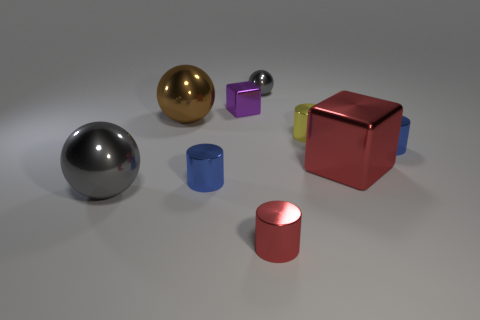Subtract all yellow cylinders. How many gray balls are left? 2 Subtract all gray balls. How many balls are left? 1 Add 1 red shiny cylinders. How many objects exist? 10 Subtract all yellow cylinders. How many cylinders are left? 3 Subtract all balls. How many objects are left? 6 Subtract all cyan spheres. Subtract all gray cylinders. How many spheres are left? 3 Add 3 big metallic spheres. How many big metallic spheres are left? 5 Add 2 yellow shiny cylinders. How many yellow shiny cylinders exist? 3 Subtract 0 gray blocks. How many objects are left? 9 Subtract all shiny blocks. Subtract all large gray metallic spheres. How many objects are left? 6 